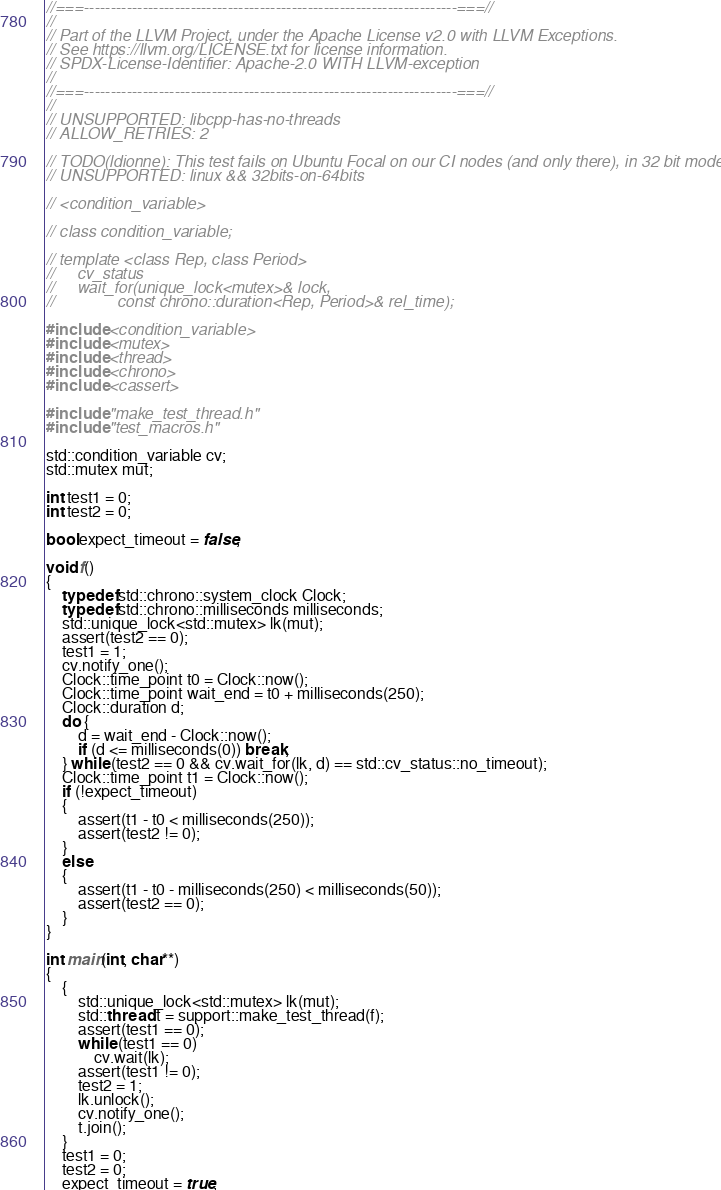Convert code to text. <code><loc_0><loc_0><loc_500><loc_500><_C++_>//===----------------------------------------------------------------------===//
//
// Part of the LLVM Project, under the Apache License v2.0 with LLVM Exceptions.
// See https://llvm.org/LICENSE.txt for license information.
// SPDX-License-Identifier: Apache-2.0 WITH LLVM-exception
//
//===----------------------------------------------------------------------===//
//
// UNSUPPORTED: libcpp-has-no-threads
// ALLOW_RETRIES: 2

// TODO(ldionne): This test fails on Ubuntu Focal on our CI nodes (and only there), in 32 bit mode.
// UNSUPPORTED: linux && 32bits-on-64bits

// <condition_variable>

// class condition_variable;

// template <class Rep, class Period>
//     cv_status
//     wait_for(unique_lock<mutex>& lock,
//              const chrono::duration<Rep, Period>& rel_time);

#include <condition_variable>
#include <mutex>
#include <thread>
#include <chrono>
#include <cassert>

#include "make_test_thread.h"
#include "test_macros.h"

std::condition_variable cv;
std::mutex mut;

int test1 = 0;
int test2 = 0;

bool expect_timeout = false;

void f()
{
    typedef std::chrono::system_clock Clock;
    typedef std::chrono::milliseconds milliseconds;
    std::unique_lock<std::mutex> lk(mut);
    assert(test2 == 0);
    test1 = 1;
    cv.notify_one();
    Clock::time_point t0 = Clock::now();
    Clock::time_point wait_end = t0 + milliseconds(250);
    Clock::duration d;
    do {
        d = wait_end - Clock::now();
        if (d <= milliseconds(0)) break;
    } while (test2 == 0 && cv.wait_for(lk, d) == std::cv_status::no_timeout);
    Clock::time_point t1 = Clock::now();
    if (!expect_timeout)
    {
        assert(t1 - t0 < milliseconds(250));
        assert(test2 != 0);
    }
    else
    {
        assert(t1 - t0 - milliseconds(250) < milliseconds(50));
        assert(test2 == 0);
    }
}

int main(int, char**)
{
    {
        std::unique_lock<std::mutex> lk(mut);
        std::thread t = support::make_test_thread(f);
        assert(test1 == 0);
        while (test1 == 0)
            cv.wait(lk);
        assert(test1 != 0);
        test2 = 1;
        lk.unlock();
        cv.notify_one();
        t.join();
    }
    test1 = 0;
    test2 = 0;
    expect_timeout = true;</code> 